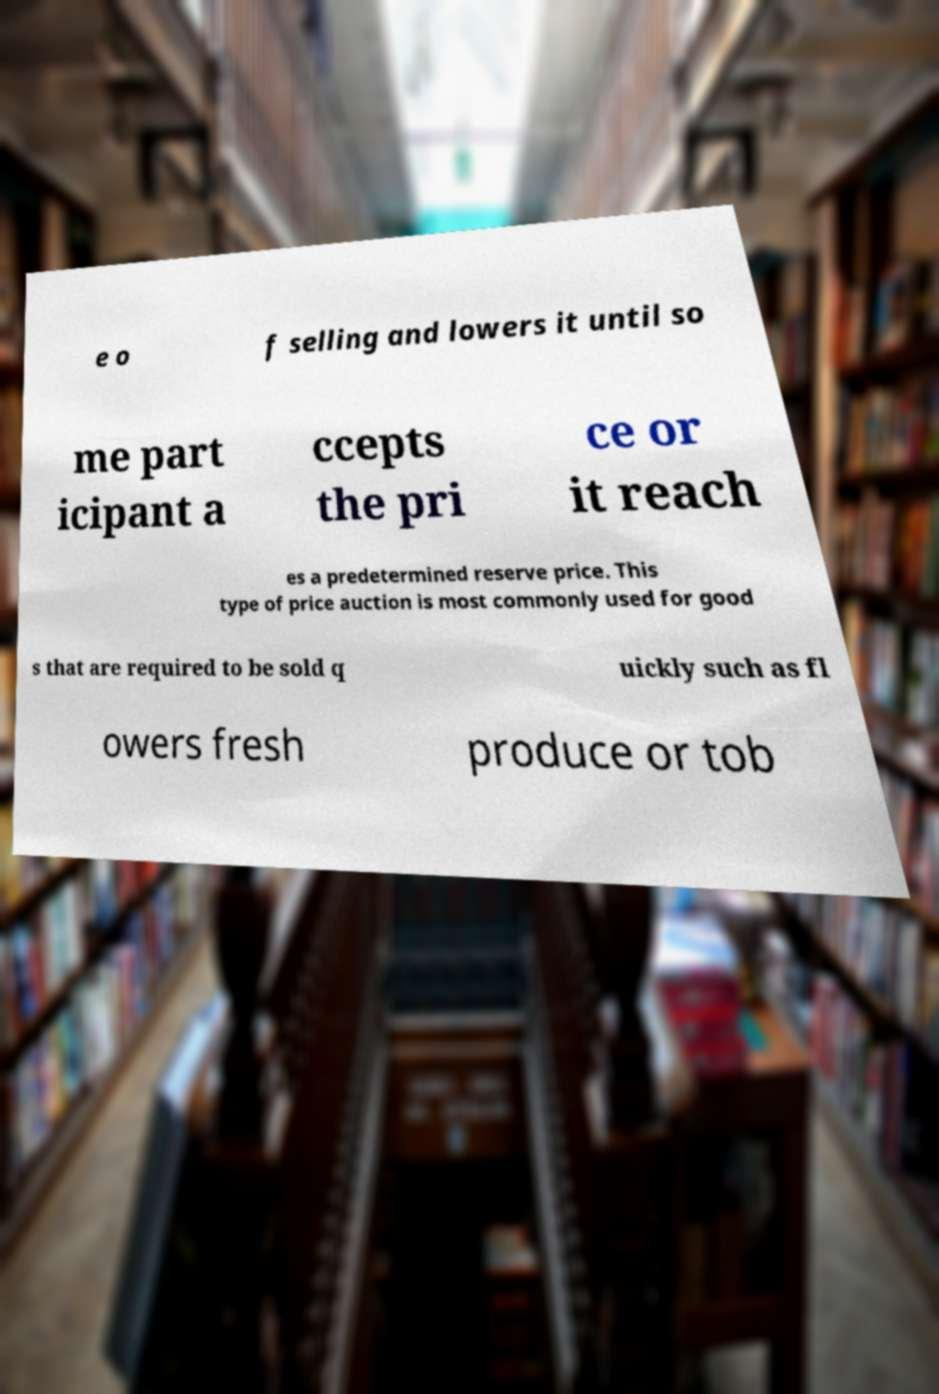I need the written content from this picture converted into text. Can you do that? e o f selling and lowers it until so me part icipant a ccepts the pri ce or it reach es a predetermined reserve price. This type of price auction is most commonly used for good s that are required to be sold q uickly such as fl owers fresh produce or tob 